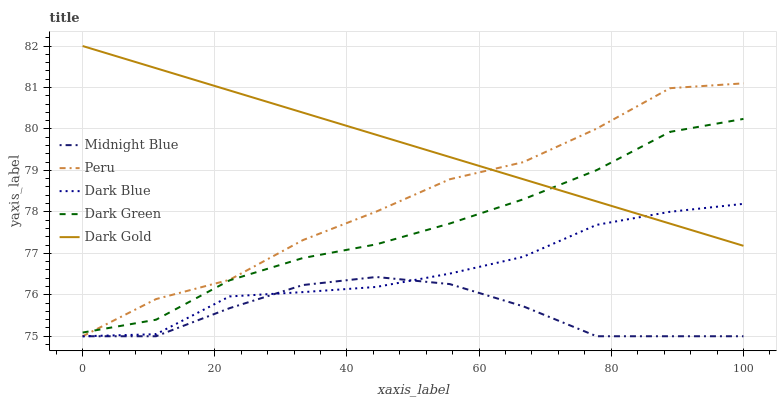Does Midnight Blue have the minimum area under the curve?
Answer yes or no. Yes. Does Dark Gold have the maximum area under the curve?
Answer yes or no. Yes. Does Dark Gold have the minimum area under the curve?
Answer yes or no. No. Does Midnight Blue have the maximum area under the curve?
Answer yes or no. No. Is Dark Gold the smoothest?
Answer yes or no. Yes. Is Peru the roughest?
Answer yes or no. Yes. Is Midnight Blue the smoothest?
Answer yes or no. No. Is Midnight Blue the roughest?
Answer yes or no. No. Does Dark Blue have the lowest value?
Answer yes or no. Yes. Does Dark Gold have the lowest value?
Answer yes or no. No. Does Dark Gold have the highest value?
Answer yes or no. Yes. Does Midnight Blue have the highest value?
Answer yes or no. No. Is Midnight Blue less than Dark Gold?
Answer yes or no. Yes. Is Dark Green greater than Dark Blue?
Answer yes or no. Yes. Does Dark Green intersect Dark Gold?
Answer yes or no. Yes. Is Dark Green less than Dark Gold?
Answer yes or no. No. Is Dark Green greater than Dark Gold?
Answer yes or no. No. Does Midnight Blue intersect Dark Gold?
Answer yes or no. No. 